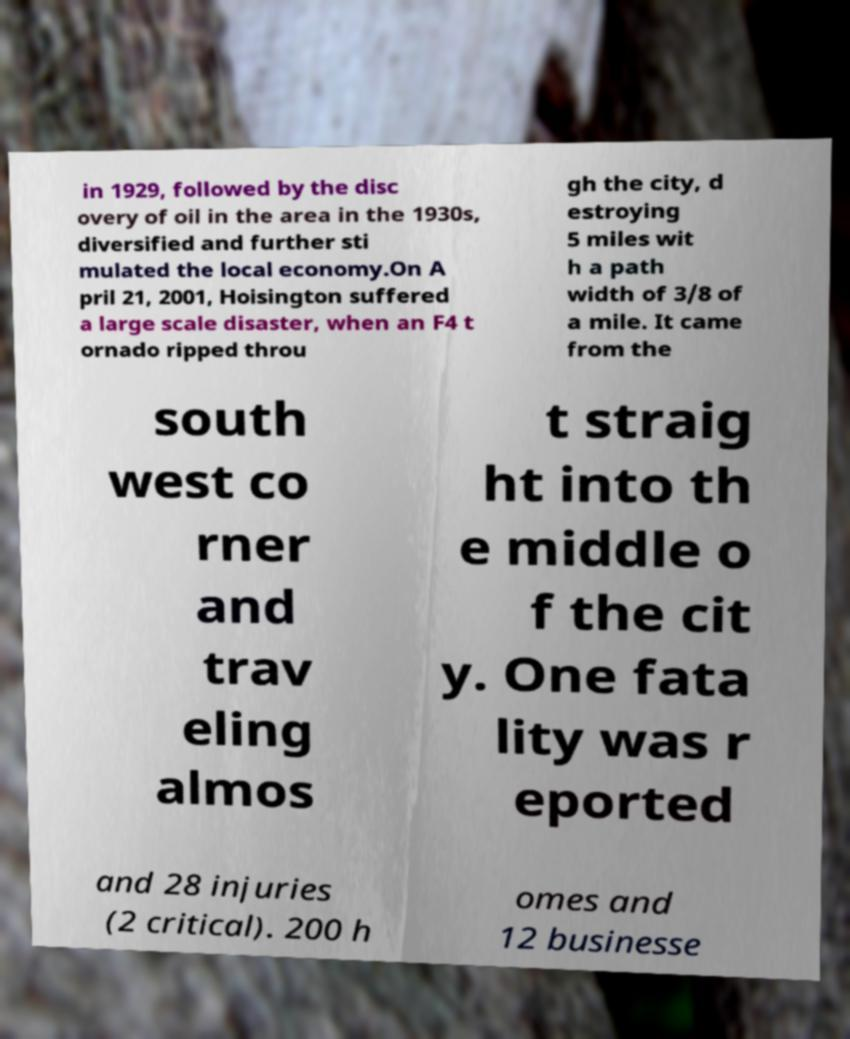What messages or text are displayed in this image? I need them in a readable, typed format. in 1929, followed by the disc overy of oil in the area in the 1930s, diversified and further sti mulated the local economy.On A pril 21, 2001, Hoisington suffered a large scale disaster, when an F4 t ornado ripped throu gh the city, d estroying 5 miles wit h a path width of 3/8 of a mile. It came from the south west co rner and trav eling almos t straig ht into th e middle o f the cit y. One fata lity was r eported and 28 injuries (2 critical). 200 h omes and 12 businesse 